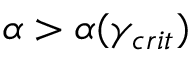<formula> <loc_0><loc_0><loc_500><loc_500>\alpha > \alpha ( \gamma _ { c r i t } )</formula> 